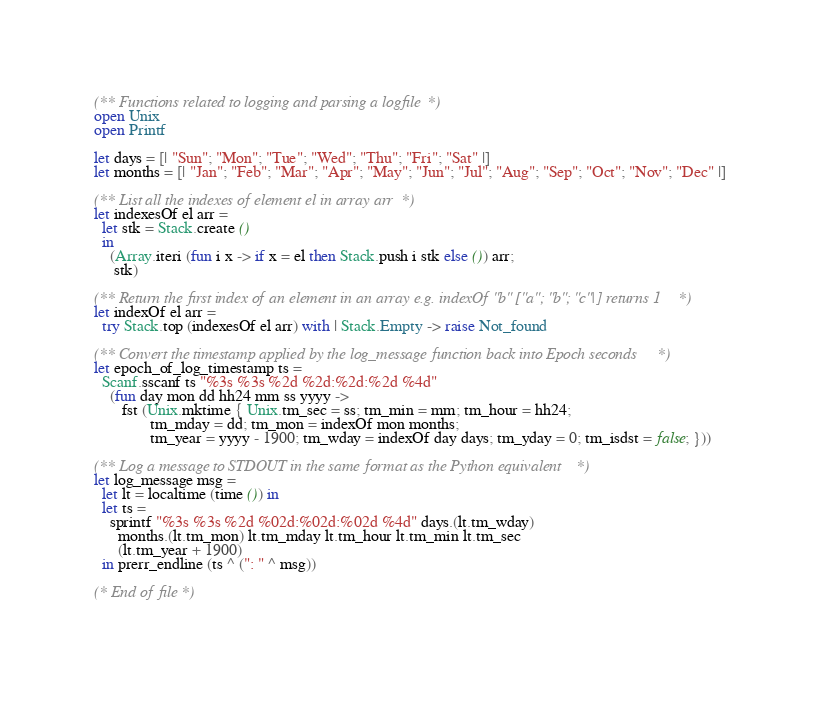<code> <loc_0><loc_0><loc_500><loc_500><_OCaml_>(** Functions related to logging and parsing a logfile *)
open Unix
open Printf
  
let days = [| "Sun"; "Mon"; "Tue"; "Wed"; "Thu"; "Fri"; "Sat" |]
let months = [| "Jan"; "Feb"; "Mar"; "Apr"; "May"; "Jun"; "Jul"; "Aug"; "Sep"; "Oct"; "Nov"; "Dec" |]
  
(** List all the indexes of element el in array arr *)
let indexesOf el arr =
  let stk = Stack.create ()
  in
    (Array.iteri (fun i x -> if x = el then Stack.push i stk else ()) arr;
     stk)
  
(** Return the first index of an element in an array e.g. indexOf "b" ["a"; "b"; "c"|] returns 1 *)
let indexOf el arr =
  try Stack.top (indexesOf el arr) with | Stack.Empty -> raise Not_found
  
(** Convert the timestamp applied by the log_message function back into Epoch seconds *)
let epoch_of_log_timestamp ts =
  Scanf.sscanf ts "%3s %3s %2d %2d:%2d:%2d %4d"
    (fun day mon dd hh24 mm ss yyyy ->
       fst (Unix.mktime { Unix.tm_sec = ss; tm_min = mm; tm_hour = hh24;
              tm_mday = dd; tm_mon = indexOf mon months;
              tm_year = yyyy - 1900; tm_wday = indexOf day days; tm_yday = 0; tm_isdst = false; }))
  
(** Log a message to STDOUT in the same format as the Python equivalent *)
let log_message msg =
  let lt = localtime (time ()) in
  let ts =
    sprintf "%3s %3s %2d %02d:%02d:%02d %4d" days.(lt.tm_wday)
      months.(lt.tm_mon) lt.tm_mday lt.tm_hour lt.tm_min lt.tm_sec
      (lt.tm_year + 1900)
  in prerr_endline (ts ^ (": " ^ msg))
  
(* End of file *)
  

</code> 